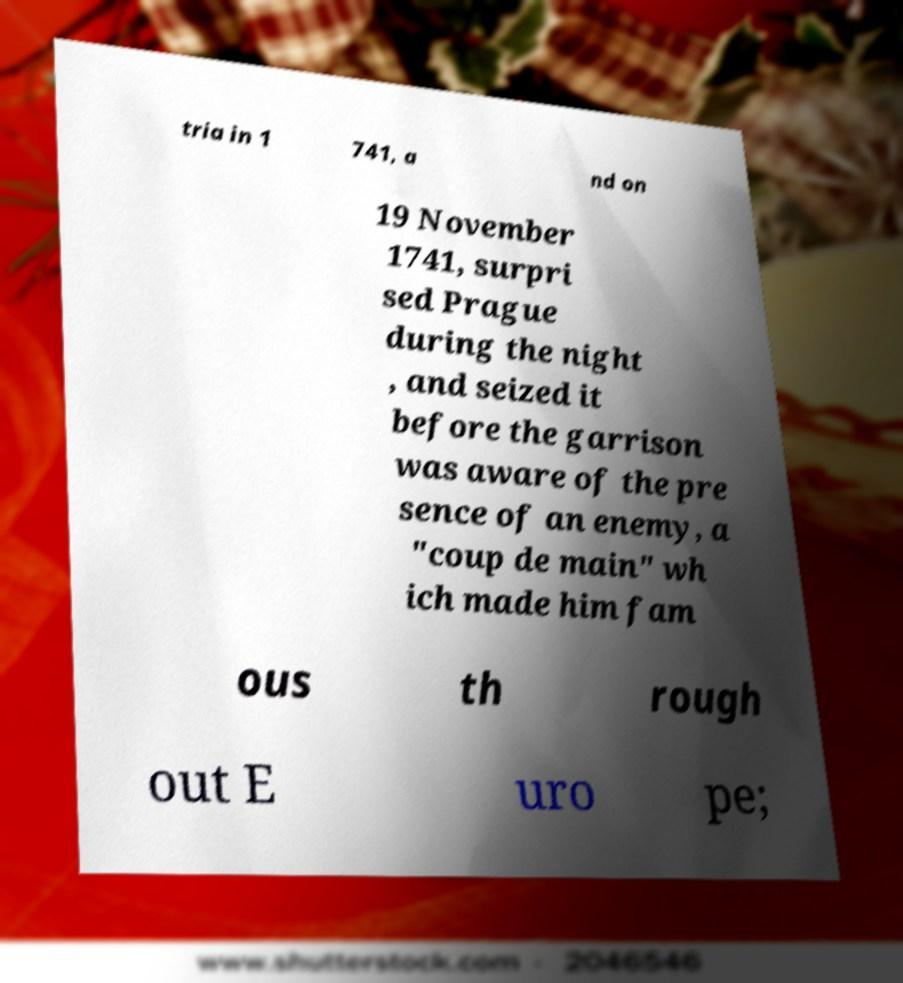Could you extract and type out the text from this image? tria in 1 741, a nd on 19 November 1741, surpri sed Prague during the night , and seized it before the garrison was aware of the pre sence of an enemy, a "coup de main" wh ich made him fam ous th rough out E uro pe; 